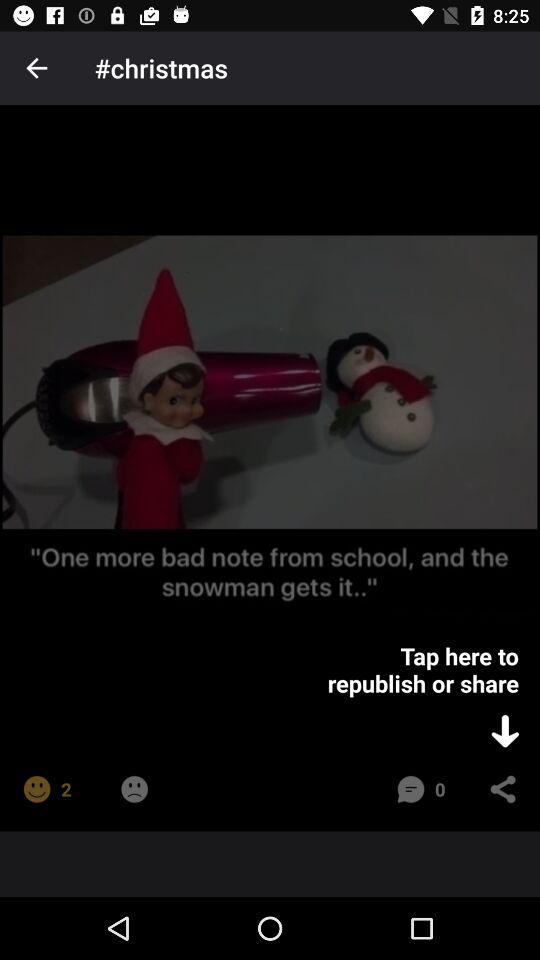What is the name of application?
When the provided information is insufficient, respond with <no answer>. <no answer> 